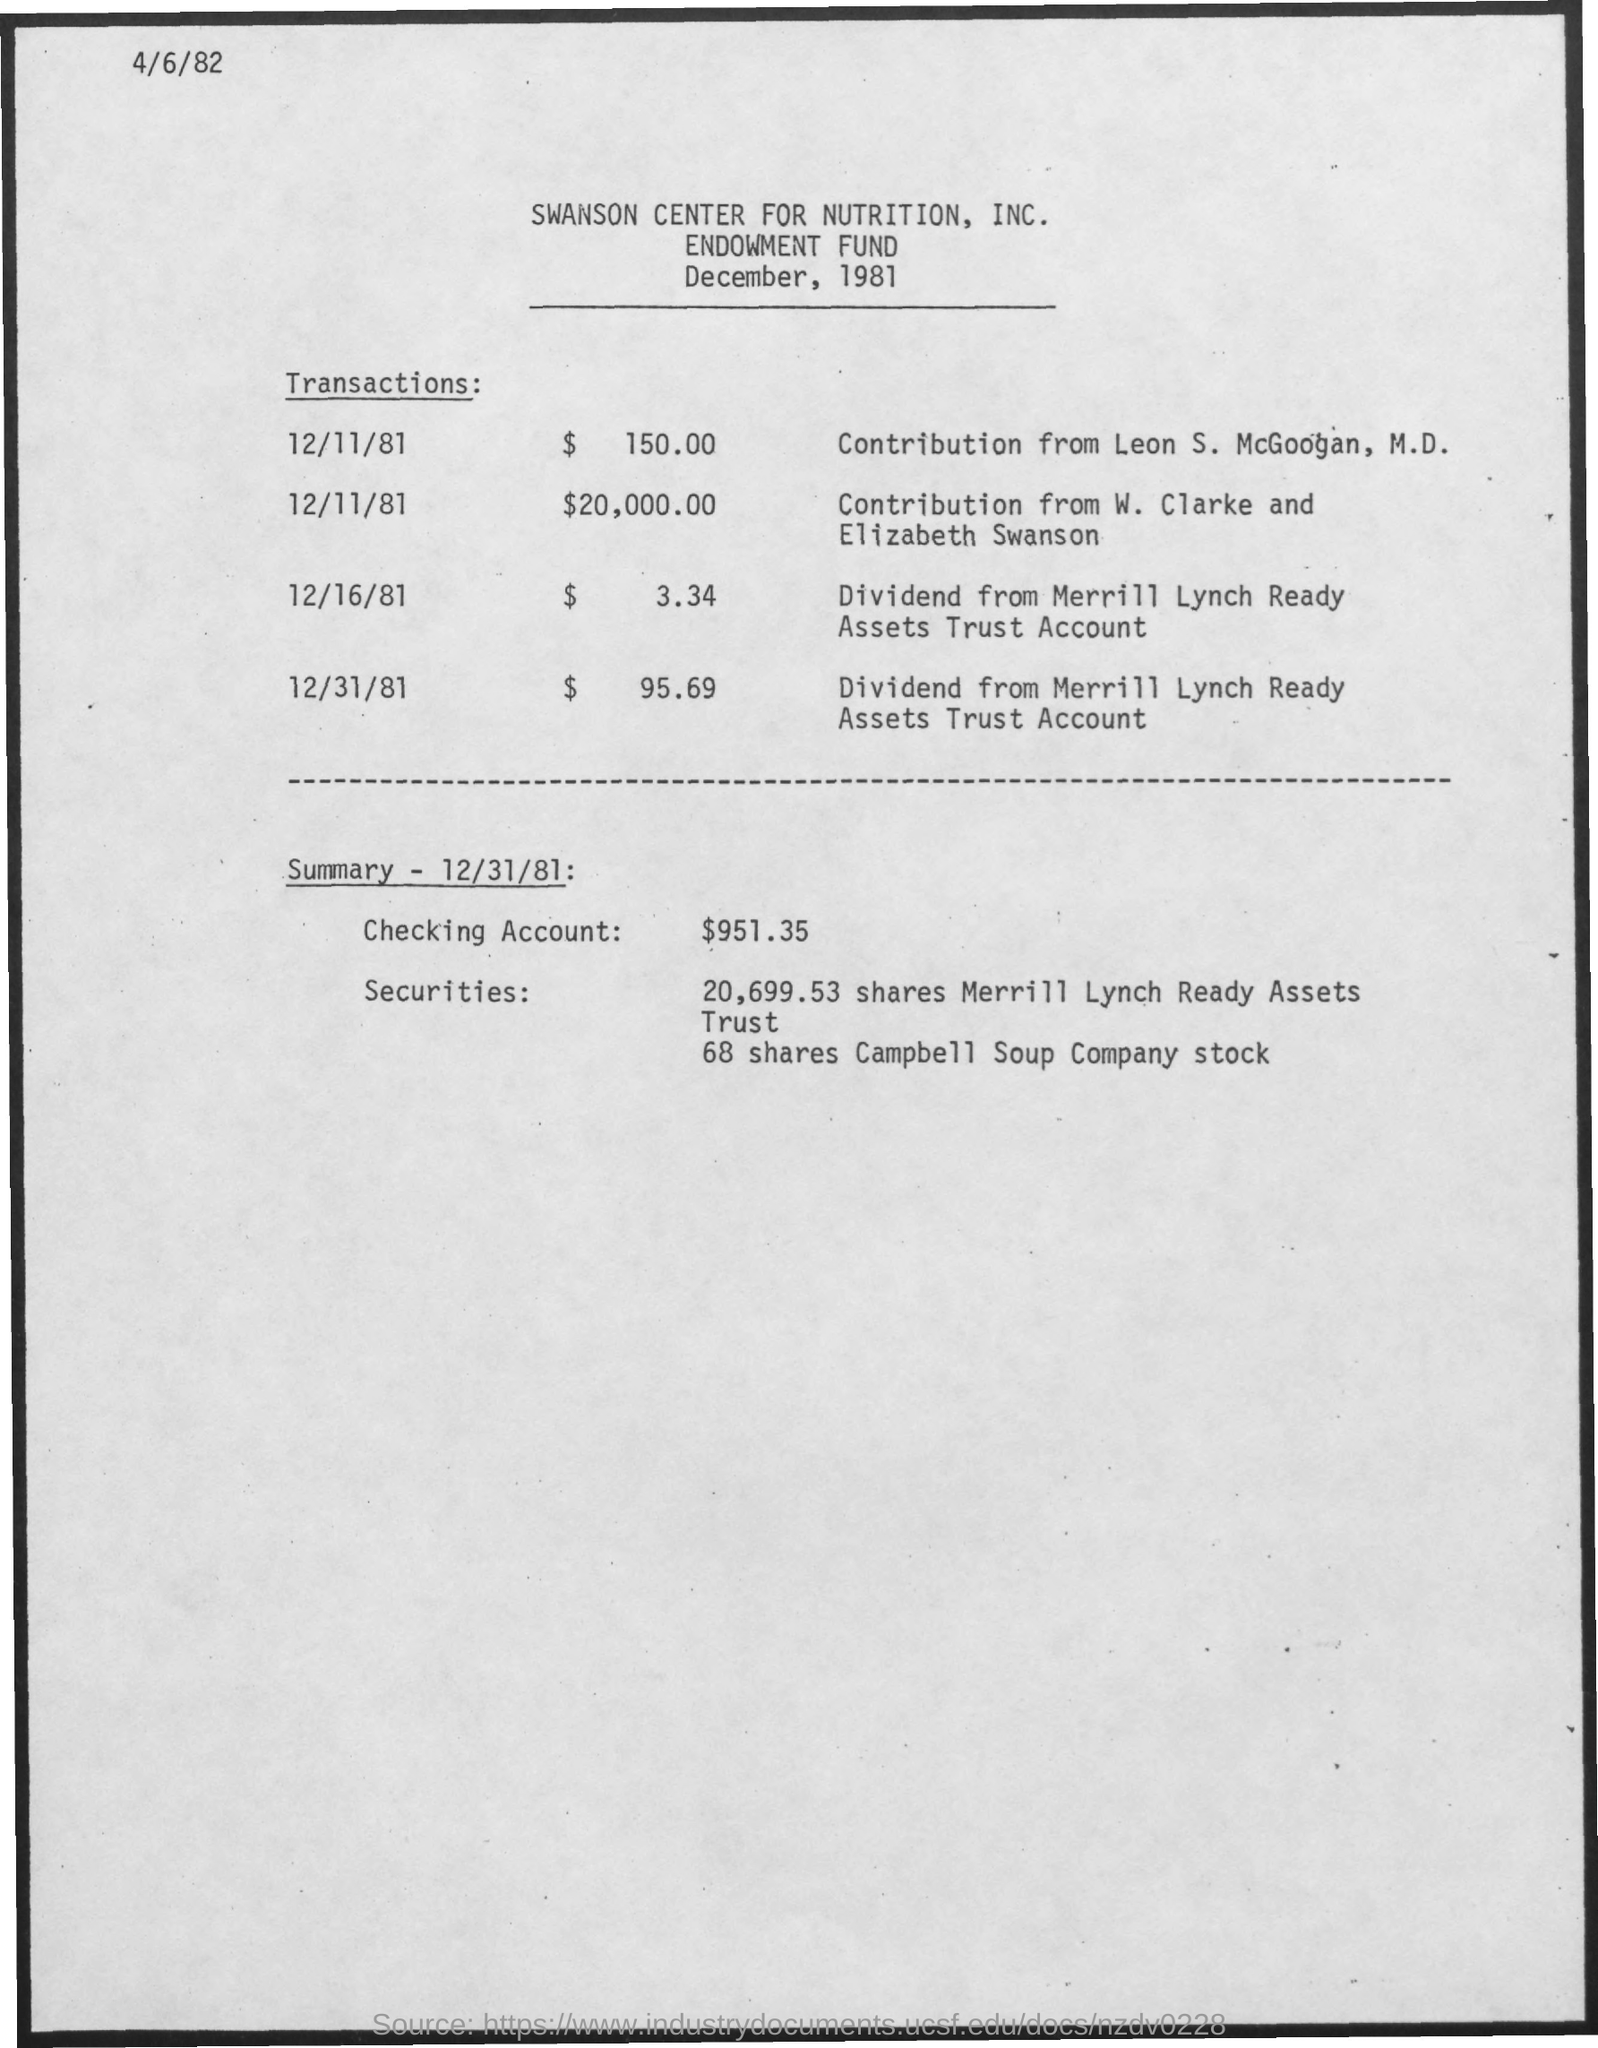Mention a couple of crucial points in this snapshot. The contribution made by W. Clarke and Elizabeth Swanson is $20,000.00. On December 11, 1981, Dr. Leon S. McGoogan contributed $150.00 to the cause. The amount in the checking account is $951.35. 